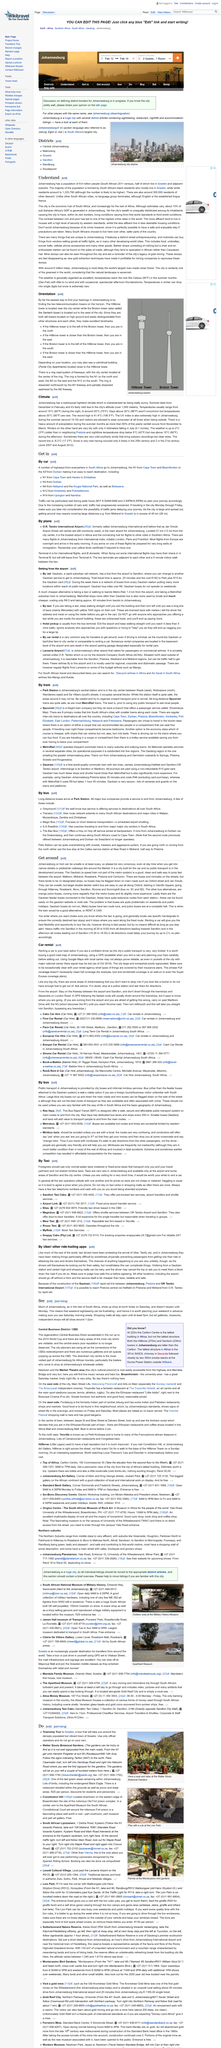Draw attention to some important aspects in this diagram. More affluent people tend to live in houses with a high level of security by western standards. The majority of South Africa's population is formed by its black residents. According to the 2011 census in South Africa, Johannesburg has a population of 9.6 million people. 